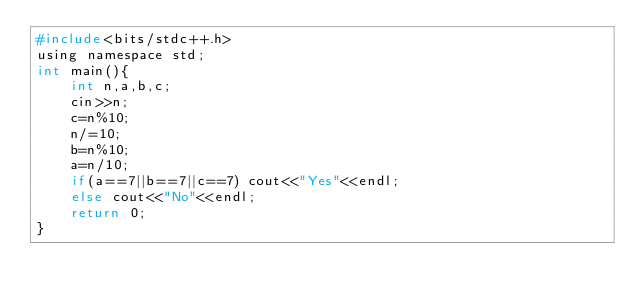Convert code to text. <code><loc_0><loc_0><loc_500><loc_500><_C_>#include<bits/stdc++.h>
using namespace std;
int main(){
	int n,a,b,c;
	cin>>n;
	c=n%10;
	n/=10;
	b=n%10;
	a=n/10;
	if(a==7||b==7||c==7) cout<<"Yes"<<endl;
	else cout<<"No"<<endl;
	return 0;
}
</code> 